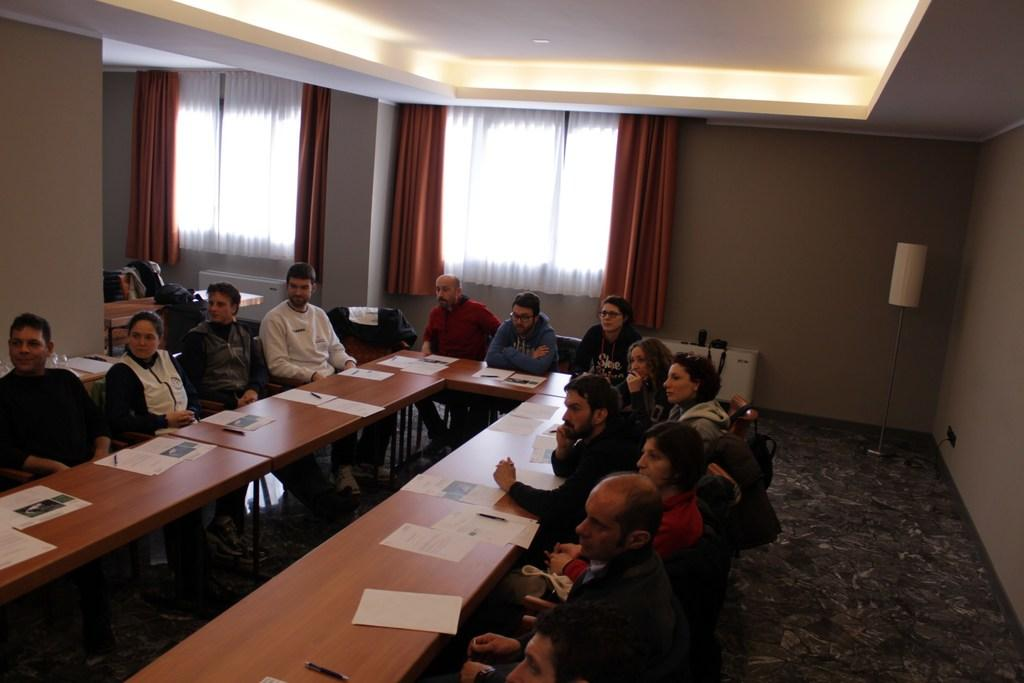How many people are in the image? There is a group of persons in the image. What are the persons doing in the image? The persons are sitting on chairs. How are the chairs arranged in the image? The chairs are arranged around a table. What can be seen in the background of the image? There is a window in the background of the image. Is there any window treatment present in the image? Yes, there is a curtain associated with the window. What direction is the cloth blowing in the image? There is no cloth present in the image, so it is not possible to determine the direction in which it might be blowing. 